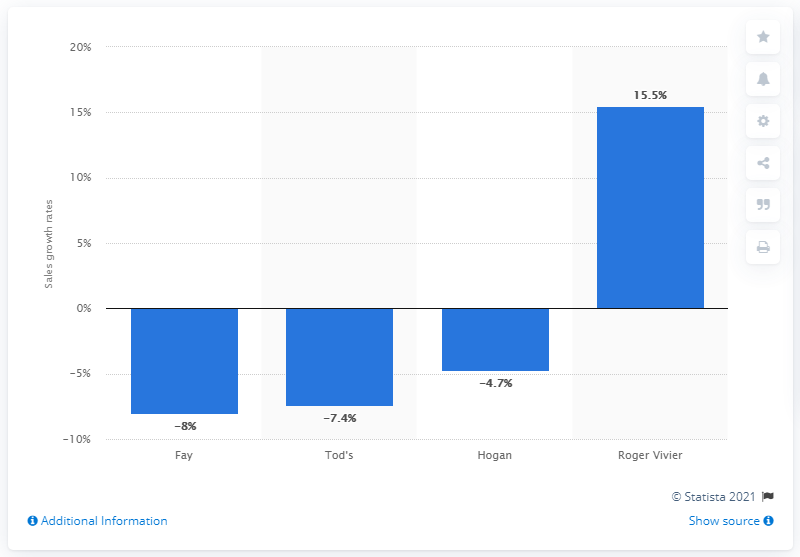Identify some key points in this picture. Tod's, an Italian fashion company, experienced a global contraction in 2019. Roger Vivier experienced a positive growth of 15.5 percent in sales in 2019, making it the successful brand of the year. 